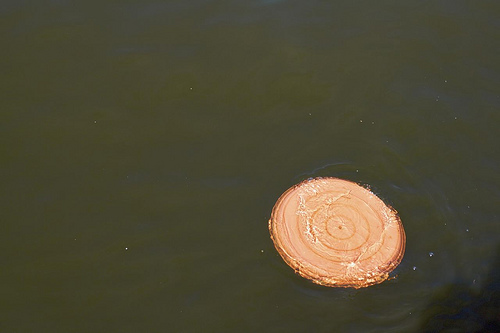<image>Is that a lake? I'm not sure, it could be a lake or not. Is that a lake? I don't know if that is a lake. It can be both a lake or not. 